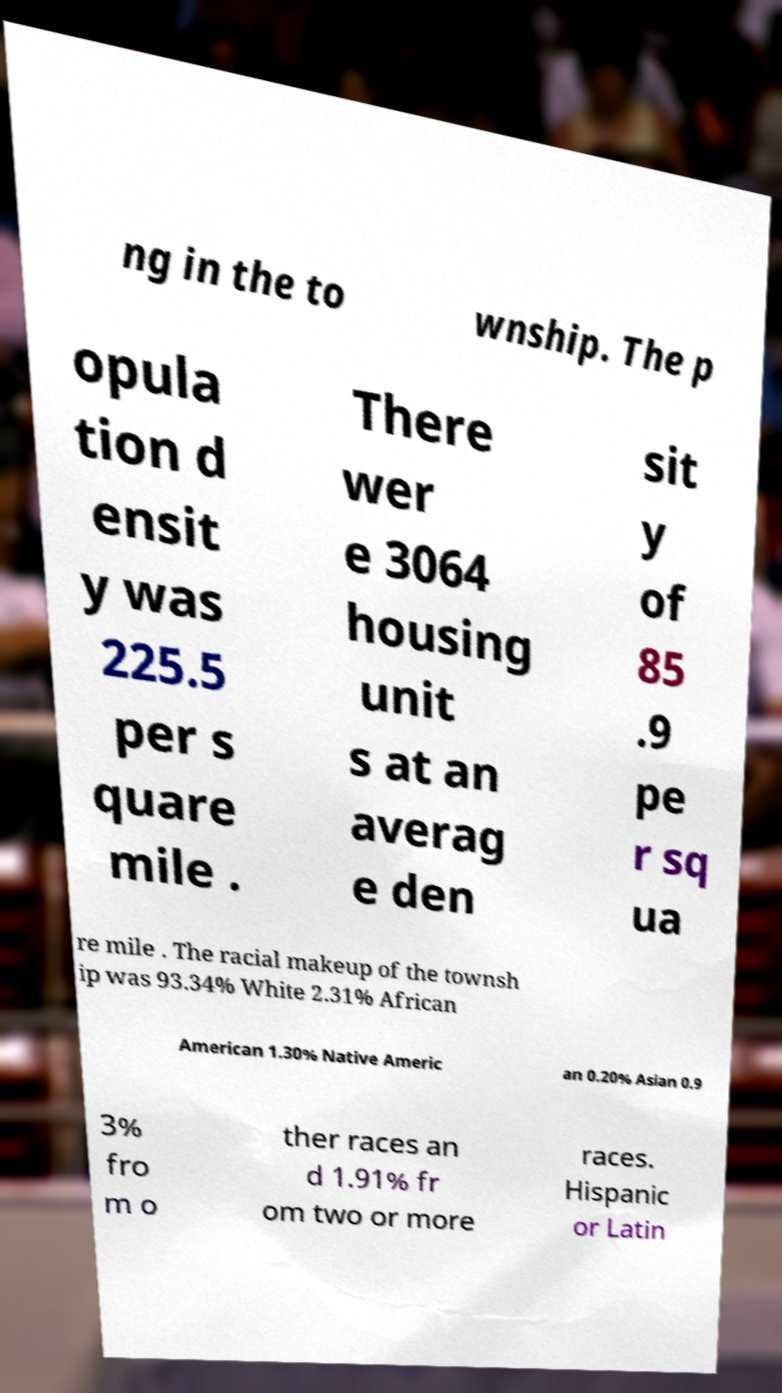Could you assist in decoding the text presented in this image and type it out clearly? ng in the to wnship. The p opula tion d ensit y was 225.5 per s quare mile . There wer e 3064 housing unit s at an averag e den sit y of 85 .9 pe r sq ua re mile . The racial makeup of the townsh ip was 93.34% White 2.31% African American 1.30% Native Americ an 0.20% Asian 0.9 3% fro m o ther races an d 1.91% fr om two or more races. Hispanic or Latin 